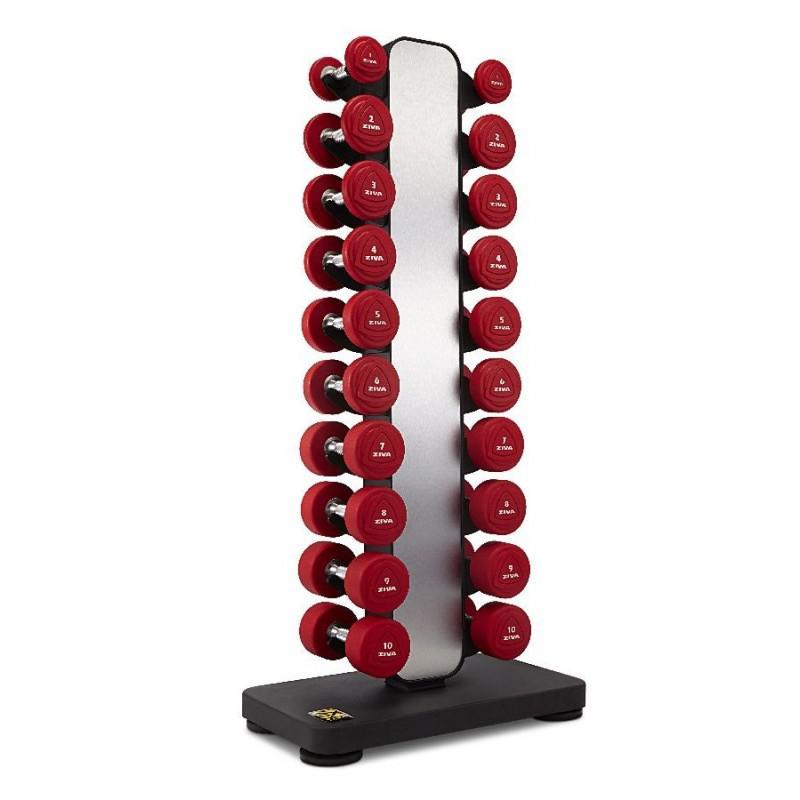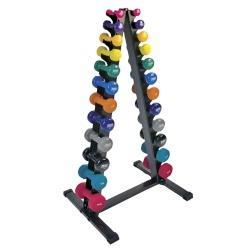The first image is the image on the left, the second image is the image on the right. Examine the images to the left and right. Is the description "Two metal racks for weights are trangular shaped, one of them black with various colored weights, the other gray with black weights." accurate? Answer yes or no. No. 